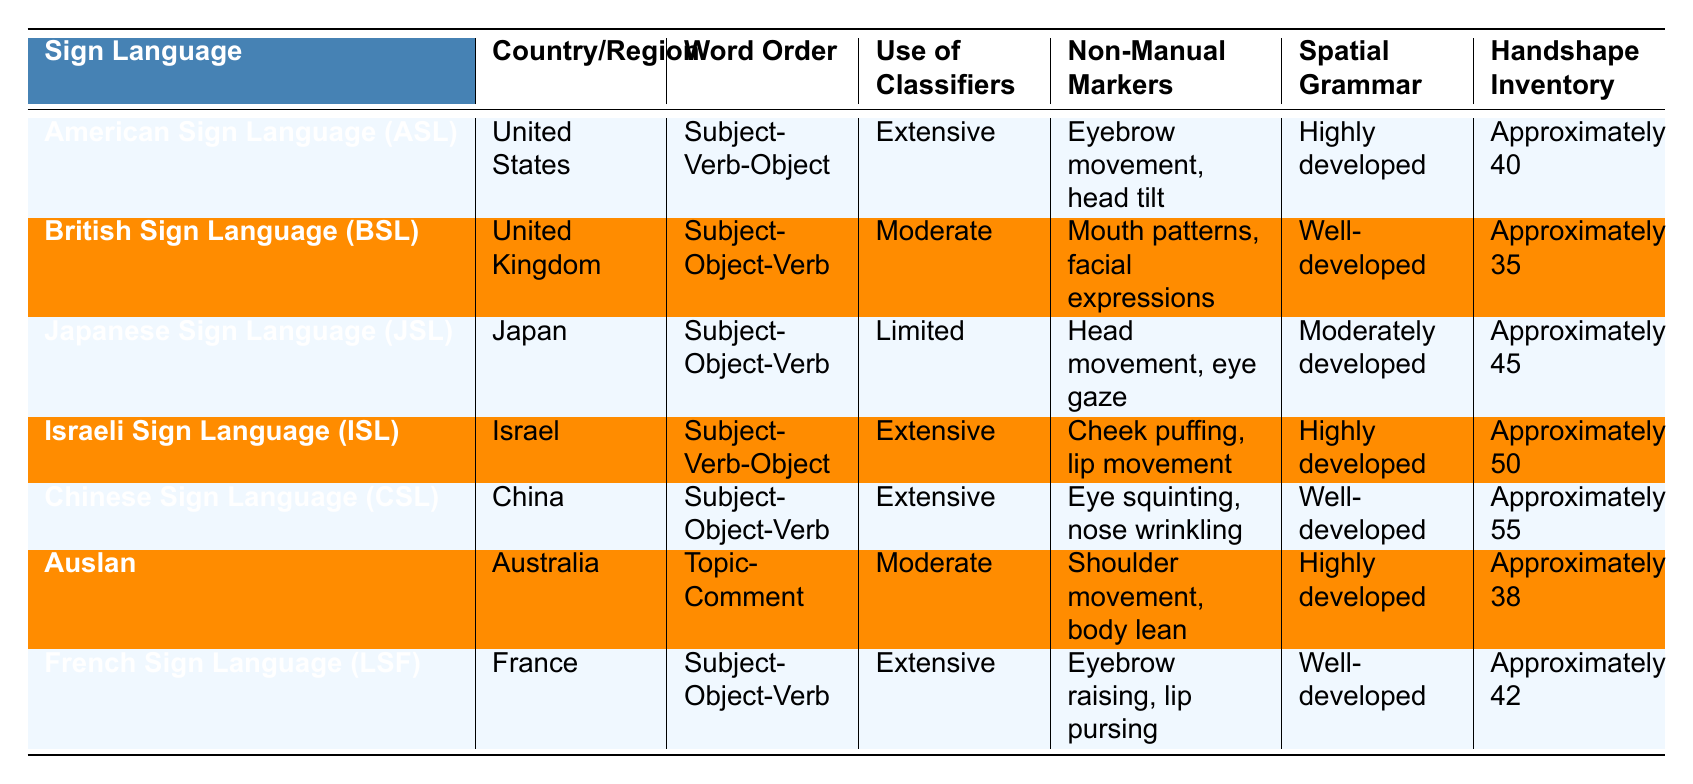What is the word order in American Sign Language (ASL)? The table indicates that American Sign Language (ASL) follows a Subject-Verb-Object word order.
Answer: Subject-Verb-Object Which sign language has the largest handshape inventory? Chinese Sign Language (CSL) has the largest handshape inventory with approximately 55 handshapes as indicated in the table.
Answer: Approximately 55 Is the use of classifiers in Japanese Sign Language (JSL) extensive? The table shows that Japanese Sign Language (JSL) has a limited use of classifiers, so the statement is false.
Answer: No How many sign languages listed utilize extensive classifiers? By counting the languages listed in the table, American Sign Language (ASL), Israeli Sign Language (ISL), Chinese Sign Language (CSL), and French Sign Language (LSF) are the four that use extensive classifiers.
Answer: Four What is the common word order for British Sign Language (BSL), Japanese Sign Language (JSL), and Chinese Sign Language (CSL)? BSL and CSL utilize a Subject-Object-Verb word order, while JSL does as well, confirming that all three languages share the same word order.
Answer: Subject-Object-Verb Which sign language demonstrates a well-developed spatial grammar? The table shows that British Sign Language (BSL), Chinese Sign Language (CSL), and French Sign Language (LSF) are all categorized as having well-developed spatial grammar.
Answer: British Sign Language, Chinese Sign Language, French Sign Language How many more handshapes does Japanese Sign Language (JSL) have compared to Auslan? The handshape inventory for JSL is approximately 45 and for Auslan approximately 38. The difference is 45 - 38 = 7.
Answer: 7 Does Auslan use non-manual markers differently than American Sign Language (ASL)? The table indicates that Auslan uses shoulder movement and body lean, while ASL uses eyebrow movement and head tilt, so they use different non-manual markers.
Answer: Yes Which sign language has a unique word order not followed by others in the table? Auslan uses Topic-Comment word order, which is different from the Subject-Verb-Object and Subject-Object-Verb word orders used by the other languages in the table.
Answer: Auslan If you combine the handshape inventories of ASL, BSL, and ISL, what is the total? Adding the handshapes: ASL has approximately 40, BSL has approximately 35, and ISL has approximately 50. Total is 40 + 35 + 50 = 125.
Answer: 125 